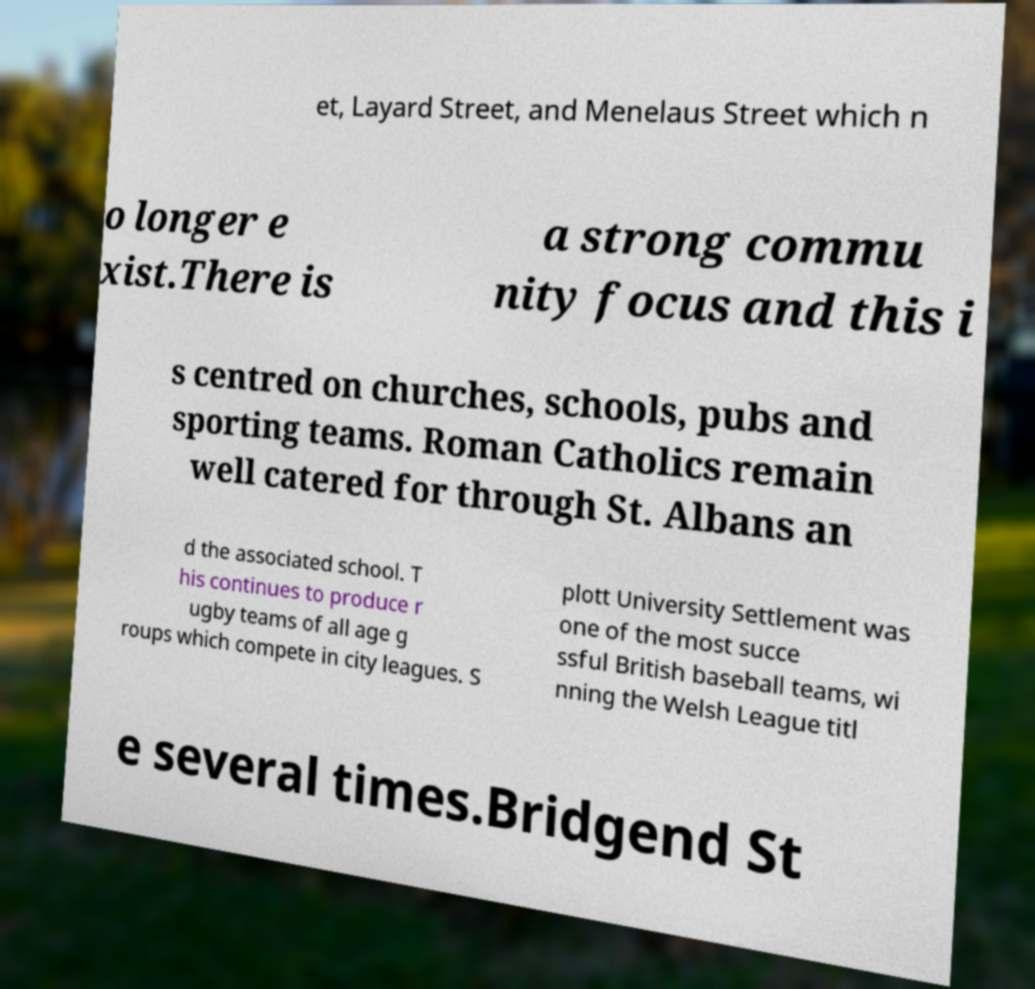What messages or text are displayed in this image? I need them in a readable, typed format. et, Layard Street, and Menelaus Street which n o longer e xist.There is a strong commu nity focus and this i s centred on churches, schools, pubs and sporting teams. Roman Catholics remain well catered for through St. Albans an d the associated school. T his continues to produce r ugby teams of all age g roups which compete in city leagues. S plott University Settlement was one of the most succe ssful British baseball teams, wi nning the Welsh League titl e several times.Bridgend St 